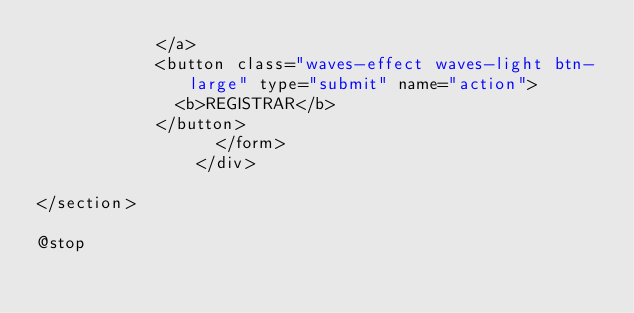Convert code to text. <code><loc_0><loc_0><loc_500><loc_500><_PHP_>            </a>
            <button class="waves-effect waves-light btn-large" type="submit" name="action">
              <b>REGISTRAR</b>
            </button>
                  </form>
                </div>
         
</section> 

@stop</code> 